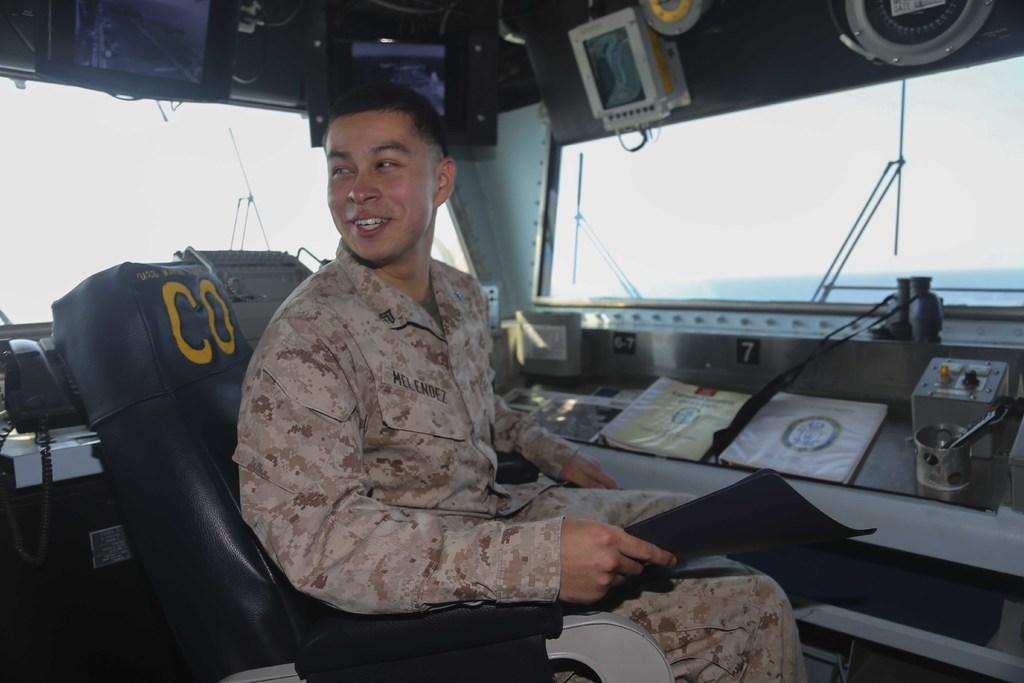Can you describe this image briefly? In this picture, we see the man in the uniform is sitting on the chair. He is smiling and he is holding a file in his hand. He might be the army commander. Beside him, we see the books or files. On the left side, we see a landline mobile. We even see the monitor. At the top, we see the monitor screens and televisions. On the right side, we see the wipers and the glass from which we can see the sky. 